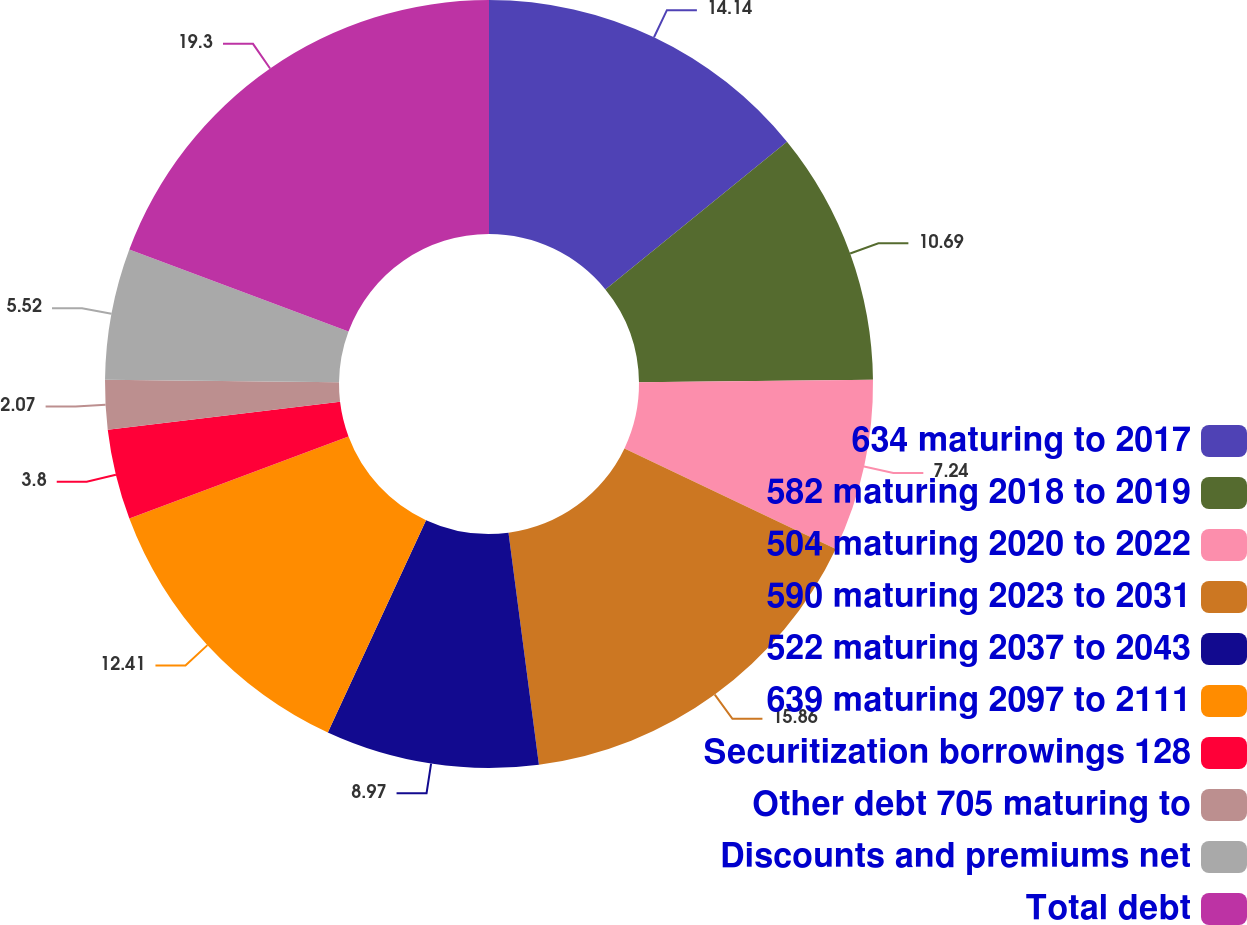Convert chart. <chart><loc_0><loc_0><loc_500><loc_500><pie_chart><fcel>634 maturing to 2017<fcel>582 maturing 2018 to 2019<fcel>504 maturing 2020 to 2022<fcel>590 maturing 2023 to 2031<fcel>522 maturing 2037 to 2043<fcel>639 maturing 2097 to 2111<fcel>Securitization borrowings 128<fcel>Other debt 705 maturing to<fcel>Discounts and premiums net<fcel>Total debt<nl><fcel>14.14%<fcel>10.69%<fcel>7.24%<fcel>15.86%<fcel>8.97%<fcel>12.41%<fcel>3.8%<fcel>2.07%<fcel>5.52%<fcel>19.31%<nl></chart> 